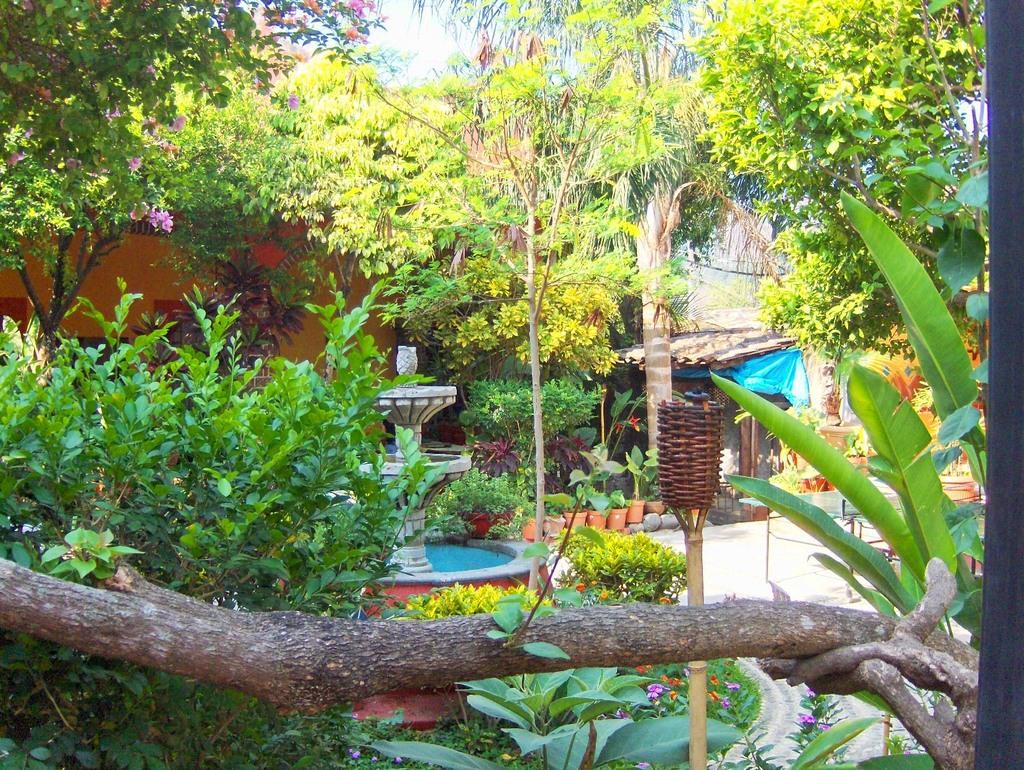What type of vegetation can be seen in the image? There are trees, plants, and grass in the image. What are the flower pots used for in the image? The flower pots are used to hold plants in the image. What material is the wooden object made of? The wooden object is made of wood. What is the object beside the wooden object? There is an object beside the wooden object, but its description is not provided in the facts. What can be seen in the background of the image? There is a house in the background of the image. What is visible in the sky in the image? The sky is visible in the image. What type of cattle can be seen grazing in the image? There is no cattle present in the image; it features trees, plants, grass, flower pots, a wooden object, an object beside the wooden object, a house in the background, and a visible sky. What type of acoustics can be heard from the wooden object in the image? The wooden object in the image is not described in a way that would allow us to determine its acoustics. 